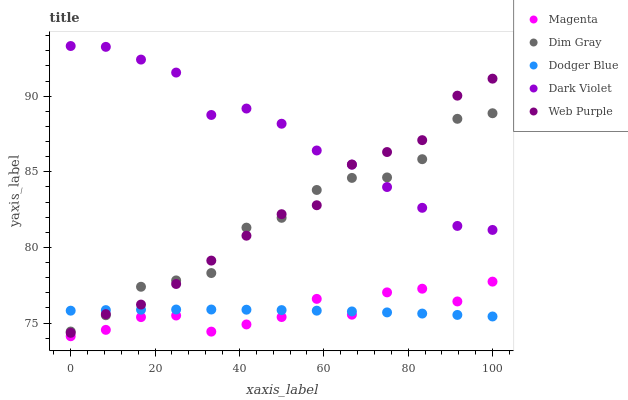Does Magenta have the minimum area under the curve?
Answer yes or no. Yes. Does Dark Violet have the maximum area under the curve?
Answer yes or no. Yes. Does Dim Gray have the minimum area under the curve?
Answer yes or no. No. Does Dim Gray have the maximum area under the curve?
Answer yes or no. No. Is Dodger Blue the smoothest?
Answer yes or no. Yes. Is Dim Gray the roughest?
Answer yes or no. Yes. Is Dim Gray the smoothest?
Answer yes or no. No. Is Dodger Blue the roughest?
Answer yes or no. No. Does Magenta have the lowest value?
Answer yes or no. Yes. Does Dim Gray have the lowest value?
Answer yes or no. No. Does Dark Violet have the highest value?
Answer yes or no. Yes. Does Dim Gray have the highest value?
Answer yes or no. No. Is Magenta less than Dark Violet?
Answer yes or no. Yes. Is Dark Violet greater than Dodger Blue?
Answer yes or no. Yes. Does Dark Violet intersect Web Purple?
Answer yes or no. Yes. Is Dark Violet less than Web Purple?
Answer yes or no. No. Is Dark Violet greater than Web Purple?
Answer yes or no. No. Does Magenta intersect Dark Violet?
Answer yes or no. No. 